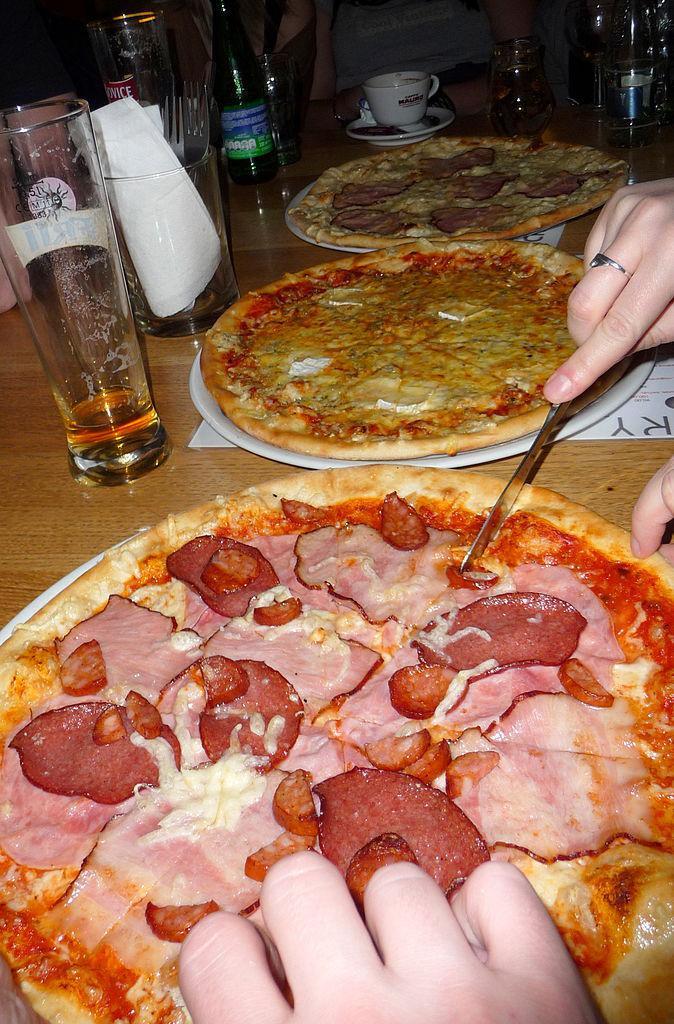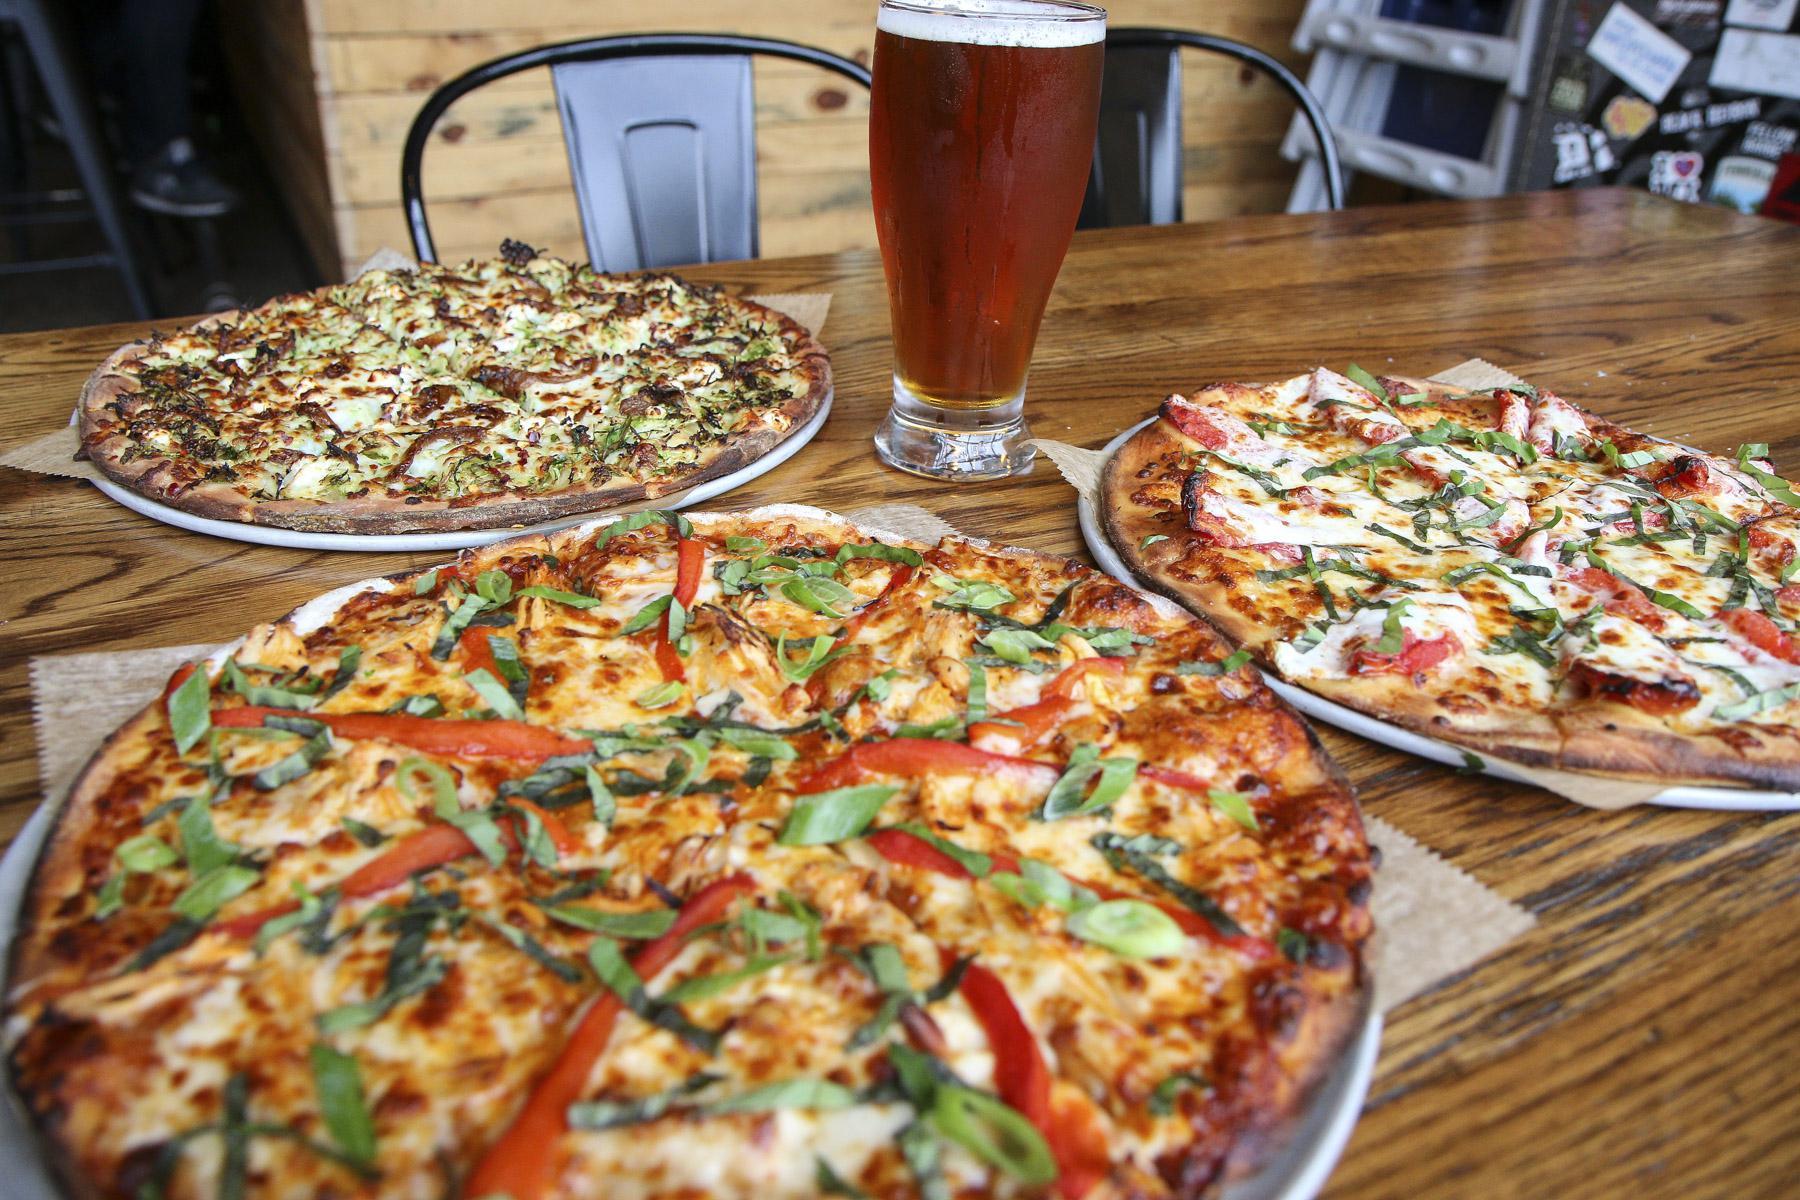The first image is the image on the left, the second image is the image on the right. Considering the images on both sides, is "In one of the images, a very long pizza appears to have three sections, with different toppings in each of the sections." valid? Answer yes or no. No. 